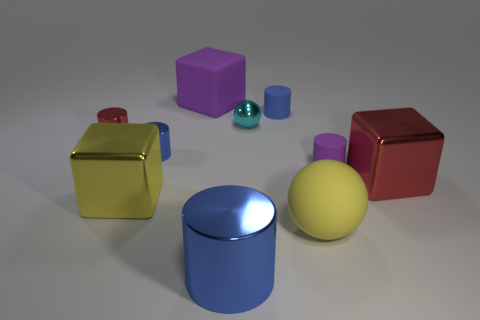How many blue cylinders must be subtracted to get 1 blue cylinders? 2 Subtract all cyan cubes. How many blue cylinders are left? 3 Subtract 2 cylinders. How many cylinders are left? 3 Subtract all red cylinders. How many cylinders are left? 4 Subtract all yellow cylinders. Subtract all gray cubes. How many cylinders are left? 5 Subtract all cubes. How many objects are left? 7 Add 1 yellow things. How many yellow things exist? 3 Subtract 0 brown cubes. How many objects are left? 10 Subtract all blue metal cylinders. Subtract all big yellow shiny cubes. How many objects are left? 7 Add 2 purple cylinders. How many purple cylinders are left? 3 